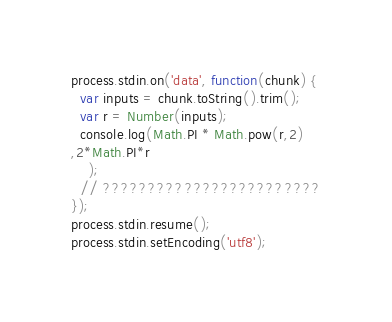Convert code to text. <code><loc_0><loc_0><loc_500><loc_500><_JavaScript_>process.stdin.on('data', function(chunk) {
  var inputs = chunk.toString().trim();
  var r = Number(inputs);
  console.log(Math.PI * Math.pow(r,2)
,2*Math.PI*r
  	);
  // ????????????????????????
});
process.stdin.resume();
process.stdin.setEncoding('utf8');</code> 